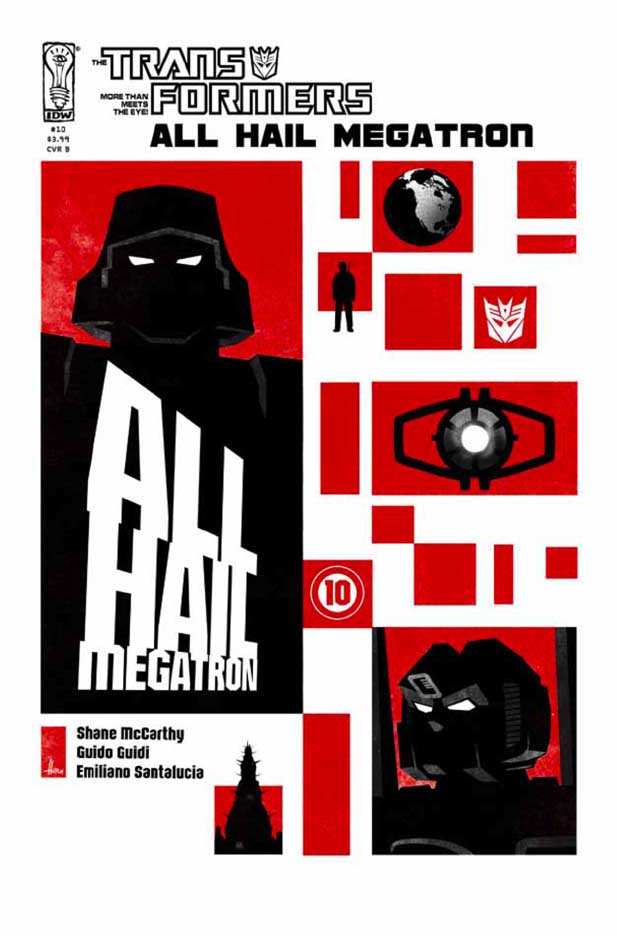How does the use of geometric shapes contribute to the overall aesthetic of the comic cover? The use of geometric shapes contributes to the overall aesthetic by creating a sense of order and modernity, which contrasts with the chaotic themes of war and conflict. The sharp angles and clean lines of the squares and rectangles lend a structured and almost mechanical feel, aligning thematically with the Transformers universe, where technology and machinery are central. Furthermore, these geometric forms guide the viewer's eye across the cover, highlighting key elements such as Megatron’s silhouette, the prominent ‘ALL HAIL’ text, and the Decepticon insignia, thereby emphasizing the gravity and focus of the narrative. 